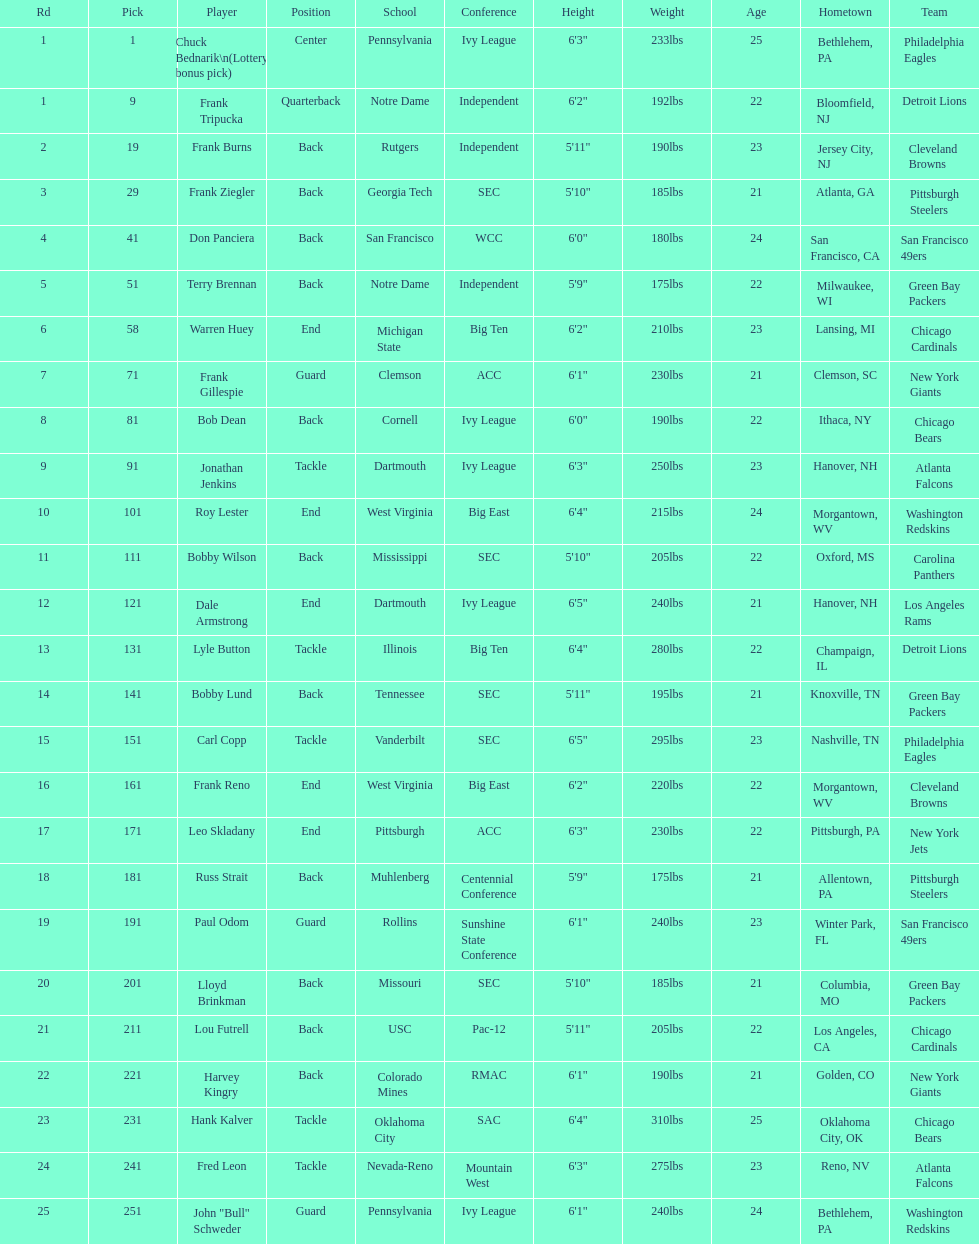Highest rd number? 25. 